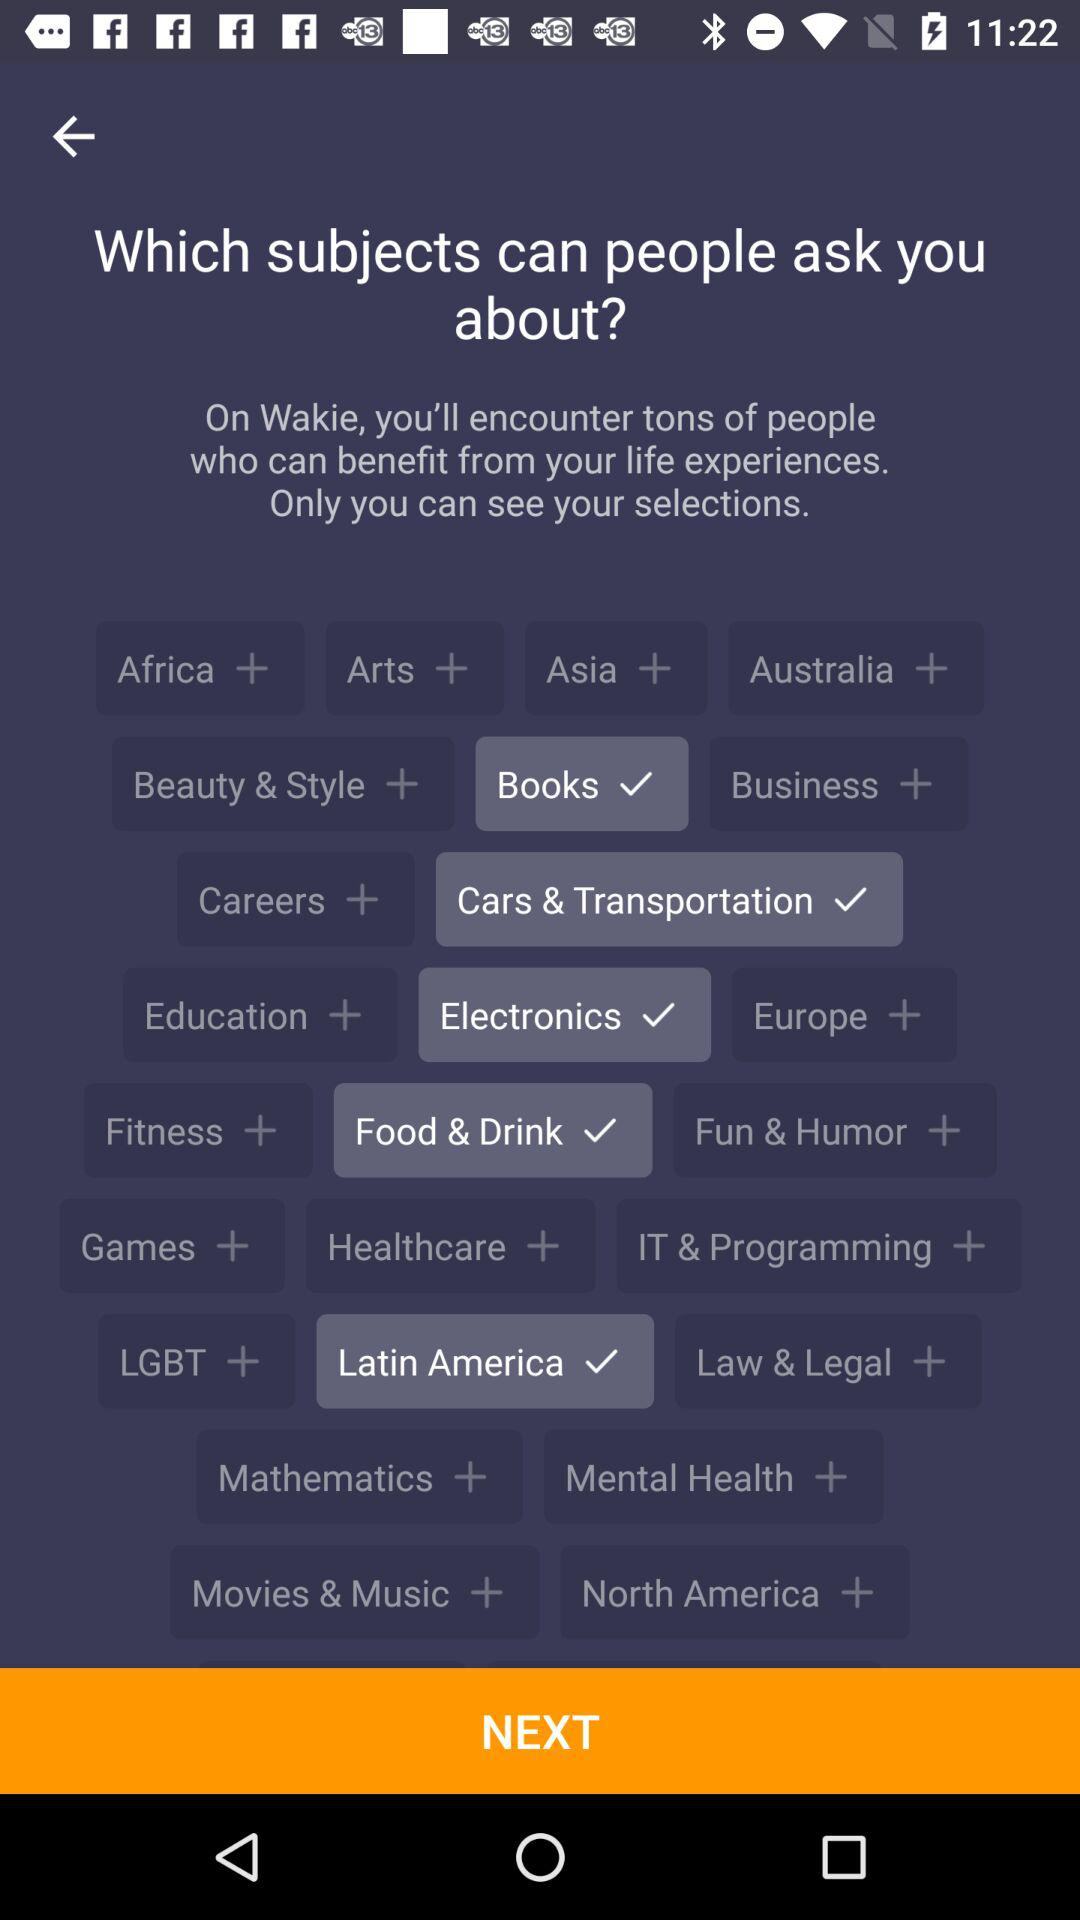Which subjects have been chosen? The subjects that have been chosen are "Books", "Cars & Transportation", "Electronics", "Food & Drink" and "Latin America". 